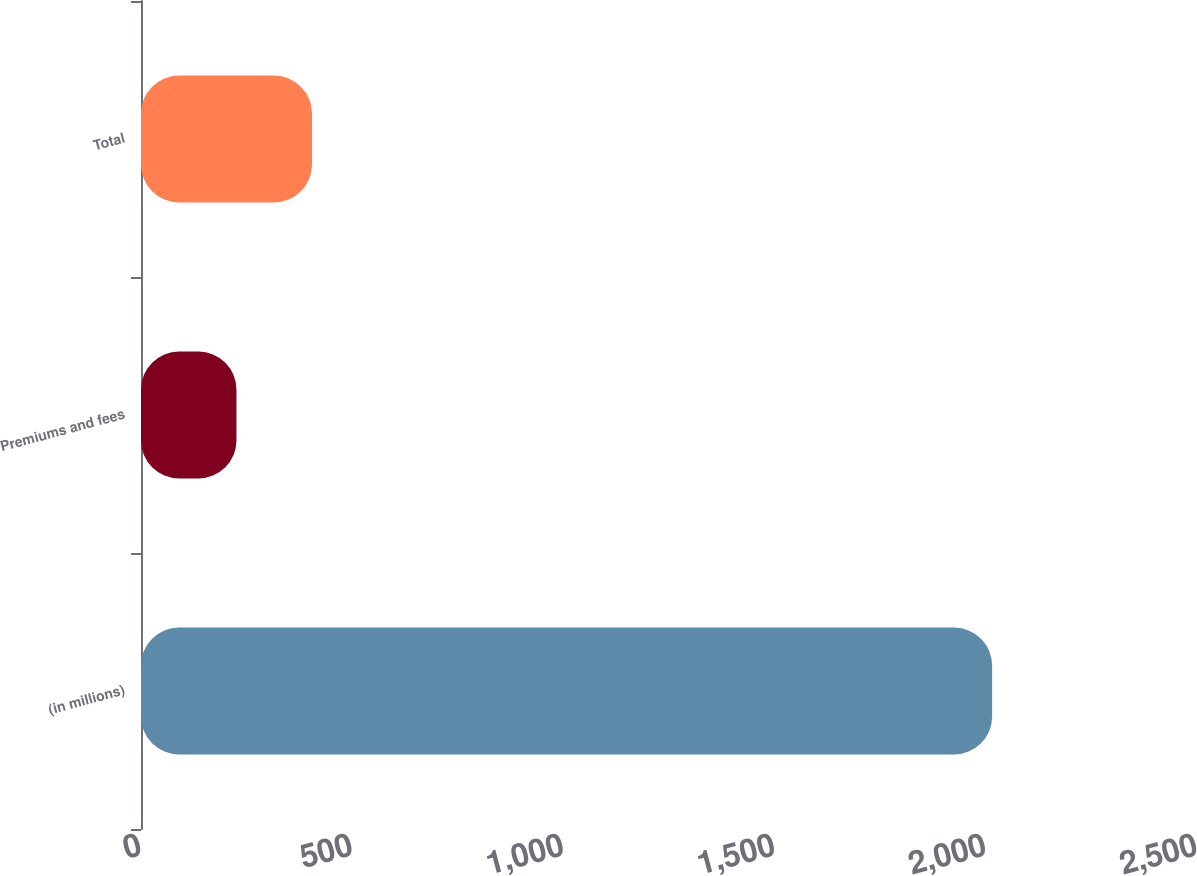Convert chart. <chart><loc_0><loc_0><loc_500><loc_500><bar_chart><fcel>(in millions)<fcel>Premiums and fees<fcel>Total<nl><fcel>2015<fcel>226<fcel>404.9<nl></chart> 